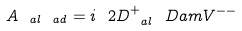Convert formula to latex. <formula><loc_0><loc_0><loc_500><loc_500>A _ { \ a l \ a d } = i \ 2 D _ { \ a l } ^ { + } \ D a m V ^ { - - }</formula> 